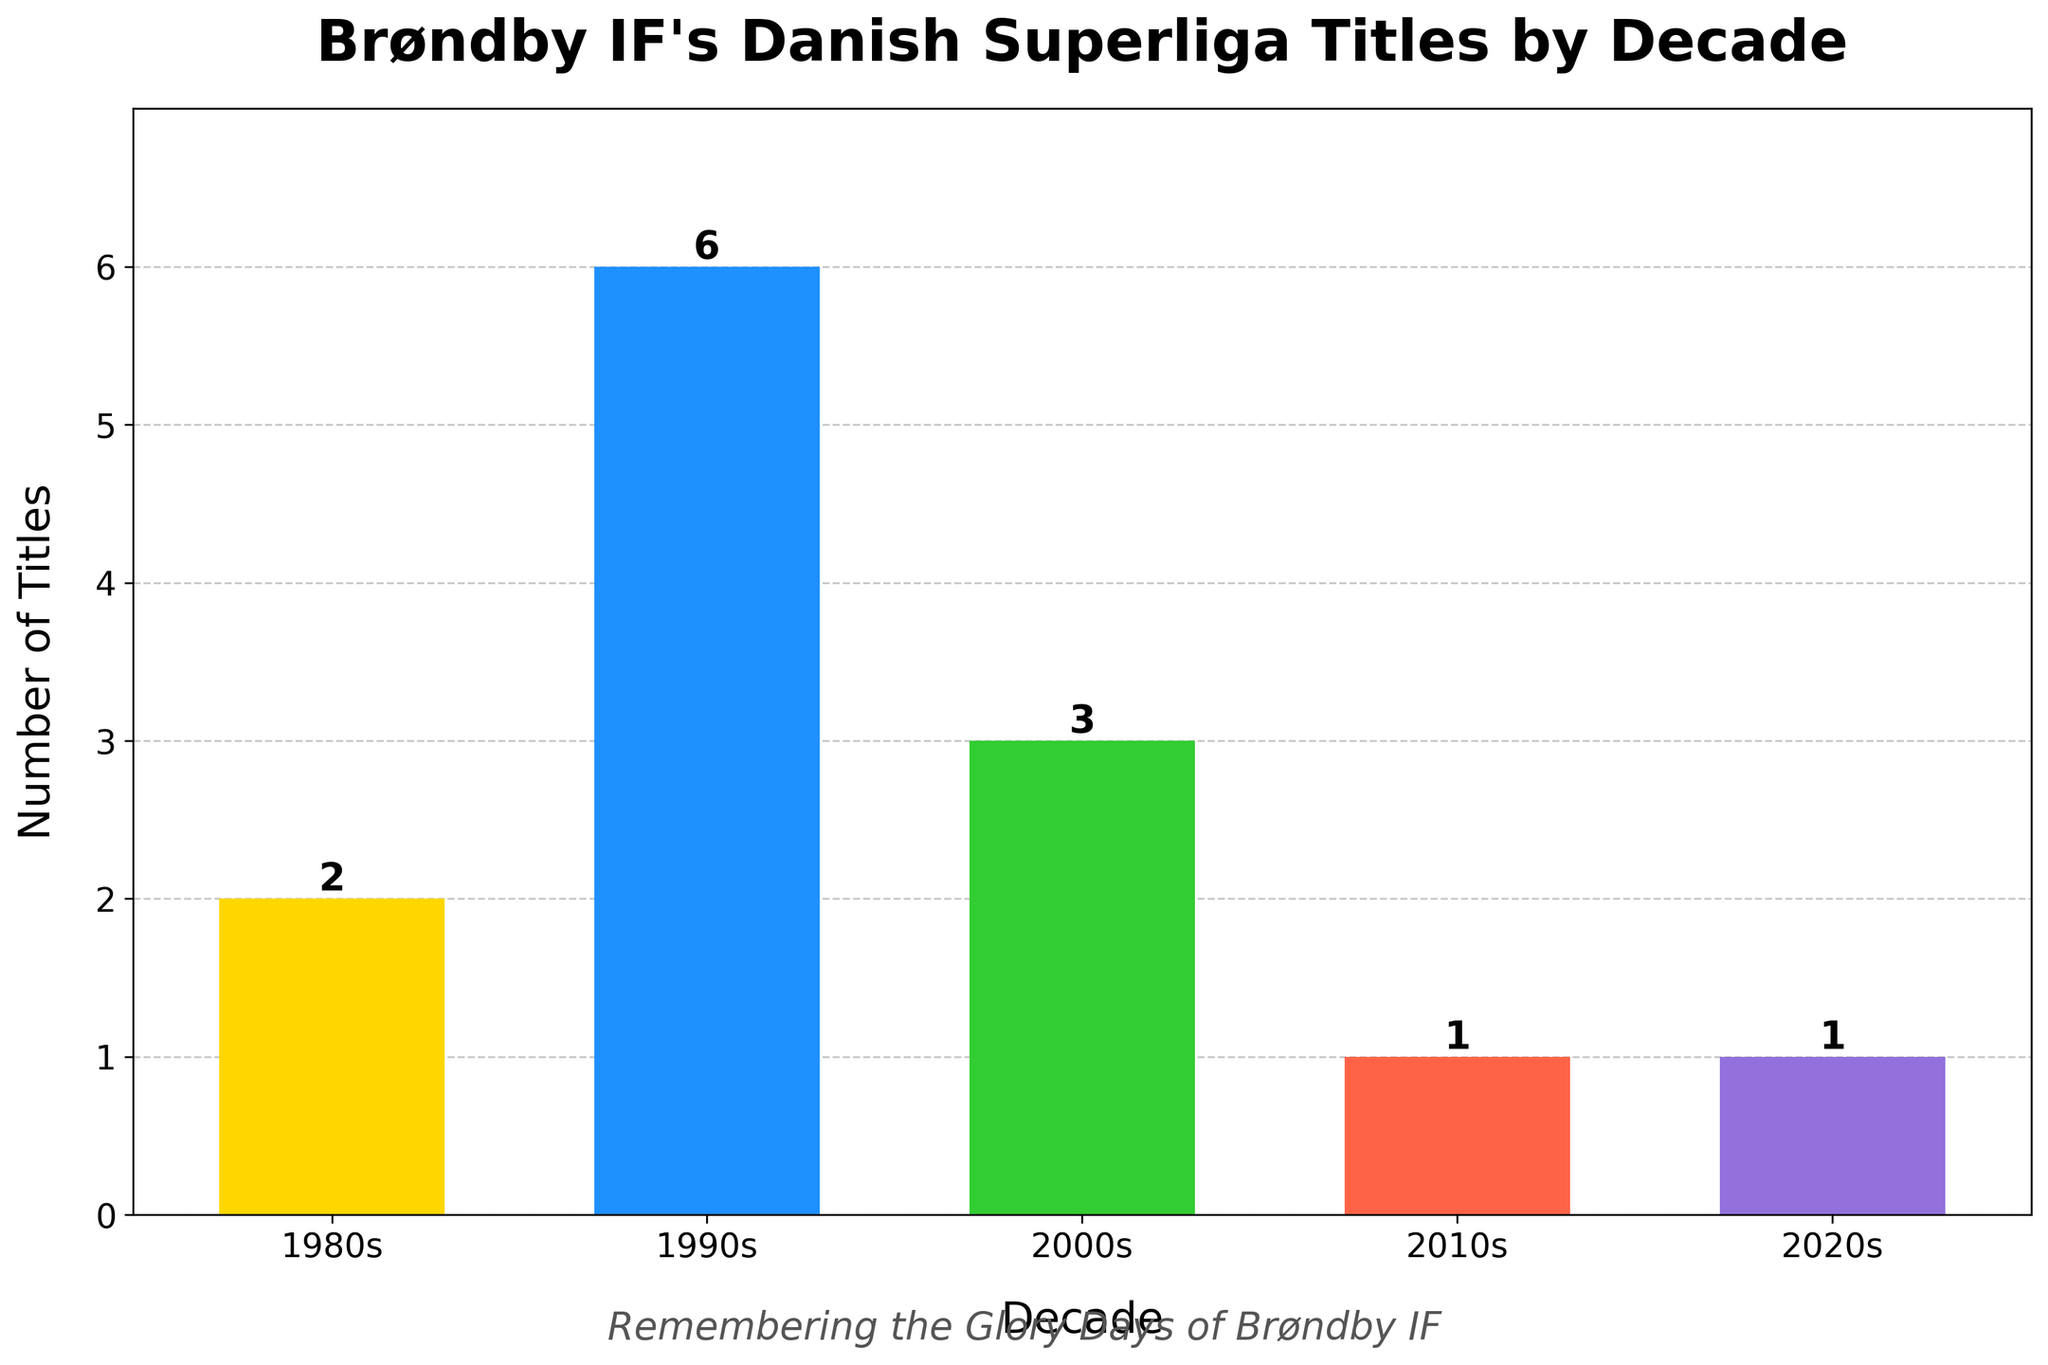Which decade did Brøndby IF win the most Danish Superliga titles? The figure shows the number of titles for each decade. The 1990s have the highest bar, indicating the most titles.
Answer: 1990s How many titles did Brøndby IF win in the 1980s and 2000s combined? Add the titles from the 1980s (2) and 2000s (3). 2 + 3 = 5.
Answer: 5 By how many titles did the 1990s exceed the 2010s? Subtract the number of titles in the 2010s (1) from the 1990s (6). 6 - 1 = 5.
Answer: 5 Which two decades have the same number of titles for Brøndby IF? The bars for the 2010s and 2020s are of equal height, both indicating 1 title each.
Answer: 2010s and 2020s What is the average number of titles per decade from the 1980s to 2020s? Add the number of titles for each decade (2+6+3+1+1 = 13) and divide by 5 (number of decades). 13 / 5 = 2.6.
Answer: 2.6 In which color is the bar for the 2020s displayed? The figure shows the bar for the 2020s in purple.
Answer: Purple How many more titles did Brøndby IF win in the 1990s compared to the 1980s? Subtract the number of titles in the 1980s (2) from the 1990s (6). 6 - 2 = 4.
Answer: 4 What is the difference between the highest and lowest number of titles won in any decade? The highest number of titles in a decade is 6 (1990s), and the lowest is 1 (2010s and 2020s). 6 - 1 = 5.
Answer: 5 How many total titles has Brøndby IF won across all decades shown? Add the total number of titles won each decade (2+6+3+1+1). 2 + 6 + 3 + 1 + 1 = 13.
Answer: 13 